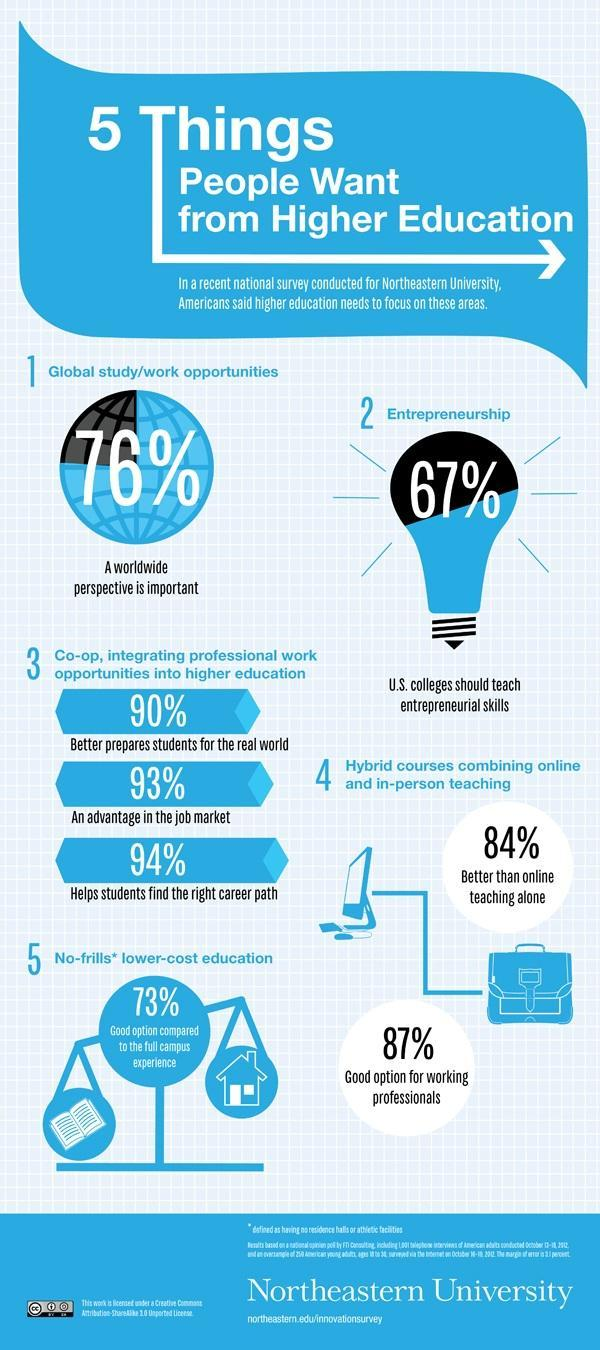What percent think that entrepreneurship skills are to be taught in colleges?
Answer the question with a short phrase. 67% 